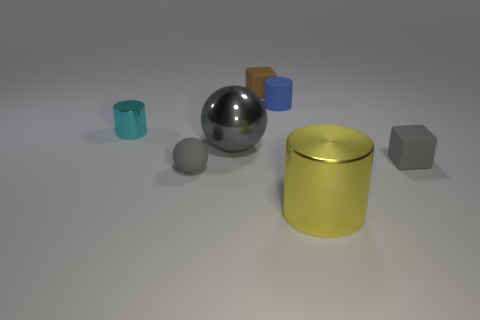The small matte thing that is to the right of the metallic object that is right of the tiny cylinder that is on the right side of the brown object is what color?
Your answer should be very brief. Gray. Does the yellow thing that is to the right of the small cyan cylinder have the same material as the large gray object that is behind the big metallic cylinder?
Offer a very short reply. Yes. There is a large thing that is in front of the tiny sphere; what is its shape?
Your answer should be compact. Cylinder. What number of things are small gray objects or small objects right of the small gray matte sphere?
Make the answer very short. 4. Are the tiny blue cylinder and the gray cube made of the same material?
Your answer should be compact. Yes. Are there an equal number of shiny balls that are to the left of the tiny blue matte cylinder and large balls that are behind the cyan object?
Provide a short and direct response. No. There is a big yellow metallic object; how many cylinders are on the left side of it?
Make the answer very short. 2. How many objects are either brown cubes or blue cylinders?
Make the answer very short. 2. What number of yellow cylinders have the same size as the cyan metal cylinder?
Your response must be concise. 0. What shape is the small gray thing right of the tiny thing that is behind the tiny blue object?
Give a very brief answer. Cube. 